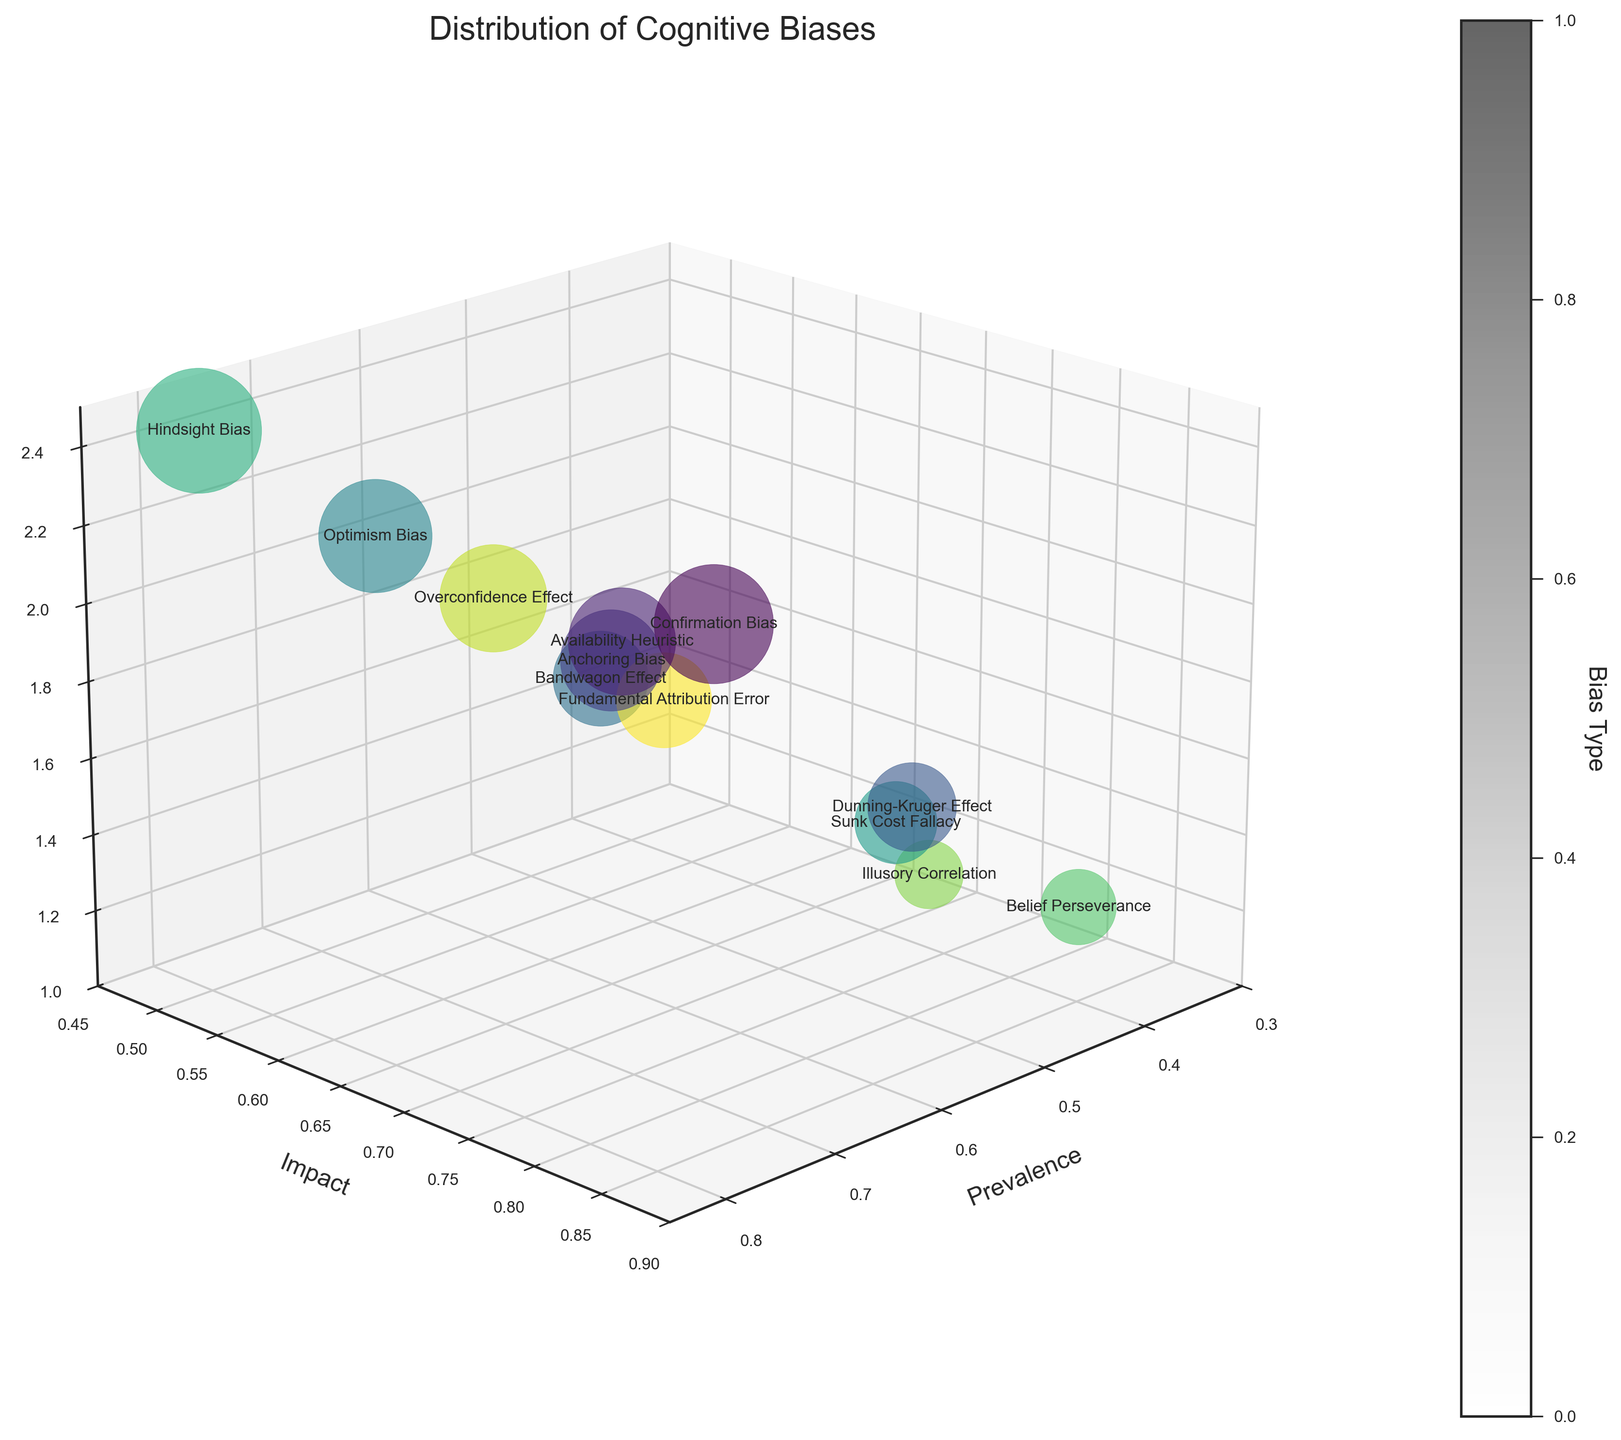What's the title of the figure? The title of the figure is prominently displayed at the top and is usually in a larger font size.
Answer: Distribution of Cognitive Biases What are the three axes labeled on the chart? Observing the labels next to each axis will inform the axes names.
Answer: Prevalence, Impact, Population Affected Which cognitive bias has the highest prevalence? By looking at the 'Prevalence' axis and identifying the highest point, the corresponding cognitive bias label can be found.
Answer: Hindsight Bias Which bias has the largest population affected? By checking the size (area) of the bubbles, the one with the largest size indicates the bias with the largest population affected.
Answer: Hindsight Bias Compare the prevalence and impact of Confirmation Bias and Optimism Bias. Which has a higher impact? Locate both Confirmation Bias and Optimism Bias on the plot and compare their values on the 'Impact' axis.
Answer: Confirmation Bias On average, what is the impact of biases with a prevalence greater than 0.65? Calculate the average impact by summing the impacts of Hindsight Bias, Confirmation Bias, and Optimism Bias, then dividing by 3. Explanation: (0.5 + 0.85 + 0.55) / 3 = 0.633 ≈ 0.63
Answer: 0.63 Which cognitive bias is least prevalent but has a high impact on decision-making? Find the bias with the lowest prevalence that sits higher on the 'Impact' axis. Explanation: Illusory Correlation has the lowest prevalence (0.35) among high-impact biases (impact > 0.70).
Answer: Illusory Correlation How does the Population Affected by Anchoring Bias compare to that of the Bandwagon Effect? Check the size (area) of the bubbles for both Anchoring Bias and Bandwagon Effect and compare their sizes; Anchoring Bias should be slightly smaller.
Answer: 185 million vs. 170 million What is the median value of the 'Impact' across all cognitive biases? List all impact values, order them, and find the middle value. Explanation: Ordered impact values: [0.50, 0.55, 0.60, 0.60, 0.65, 0.65, 0.70, 0.70, 0.75, 0.80, 0.85, 0.85]; Median is between 0.65-0.70.
Answer: 0.675 ≈ 0.68 